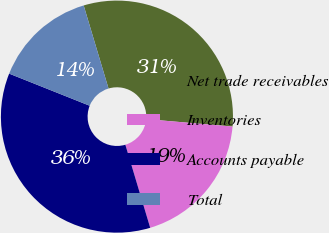Convert chart. <chart><loc_0><loc_0><loc_500><loc_500><pie_chart><fcel>Net trade receivables<fcel>Inventories<fcel>Accounts payable<fcel>Total<nl><fcel>30.99%<fcel>19.01%<fcel>35.67%<fcel>14.33%<nl></chart> 